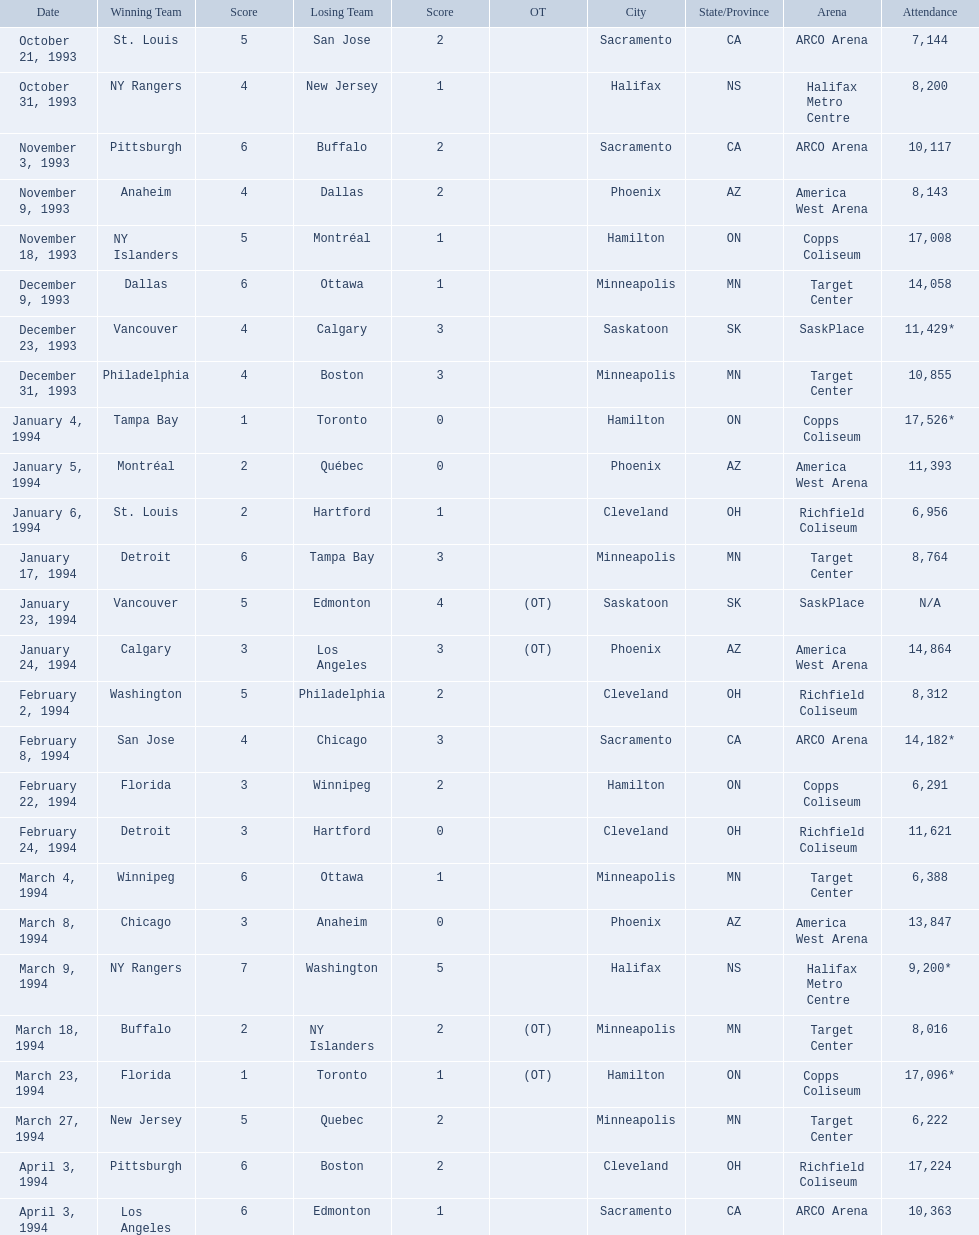What was the top attendance for a contest? 17,526*. What was the date of the event with 17,526 attendees? January 4, 1994. 